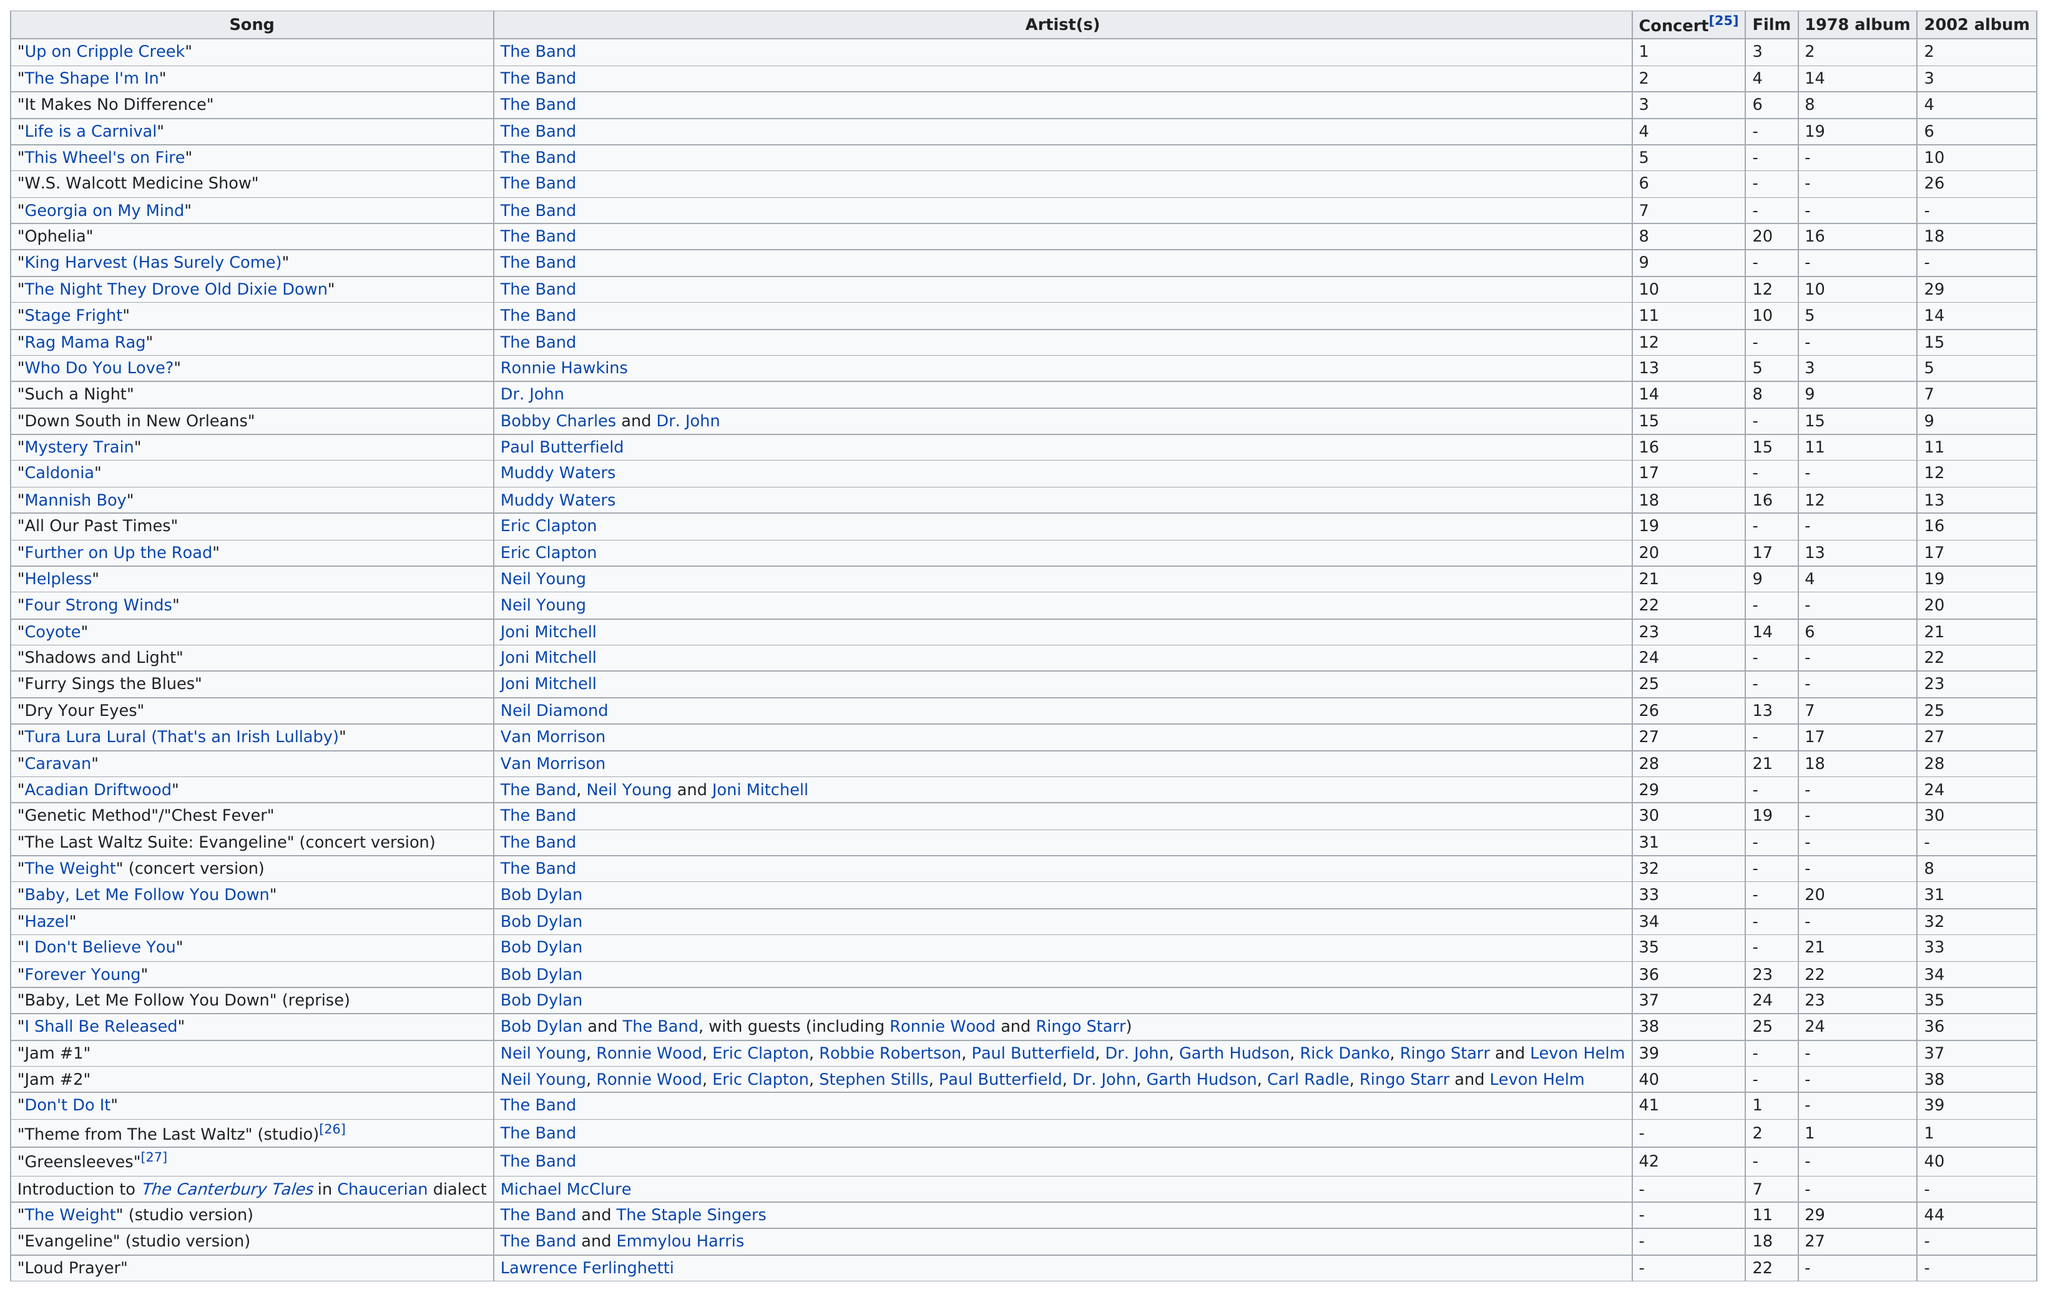Draw attention to some important aspects in this diagram. There are a total of 47 songs listed. The Band is the artist with the most concerts. The Band is the first artist on the chart. In total, there are 47 songs. The song "W.S. Walcott Medicine Show" is prior to "Georgia on My Mind". 